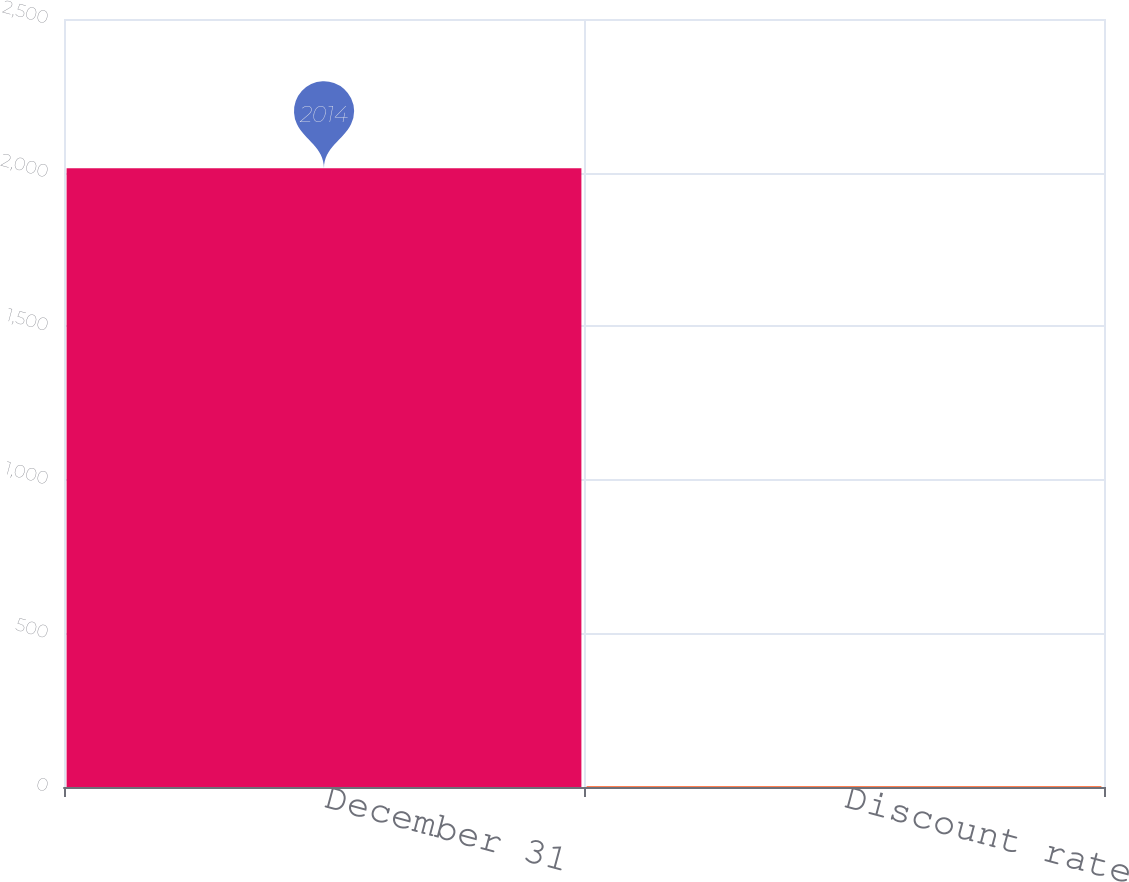Convert chart to OTSL. <chart><loc_0><loc_0><loc_500><loc_500><bar_chart><fcel>December 31<fcel>Discount rate<nl><fcel>2014<fcel>3.5<nl></chart> 